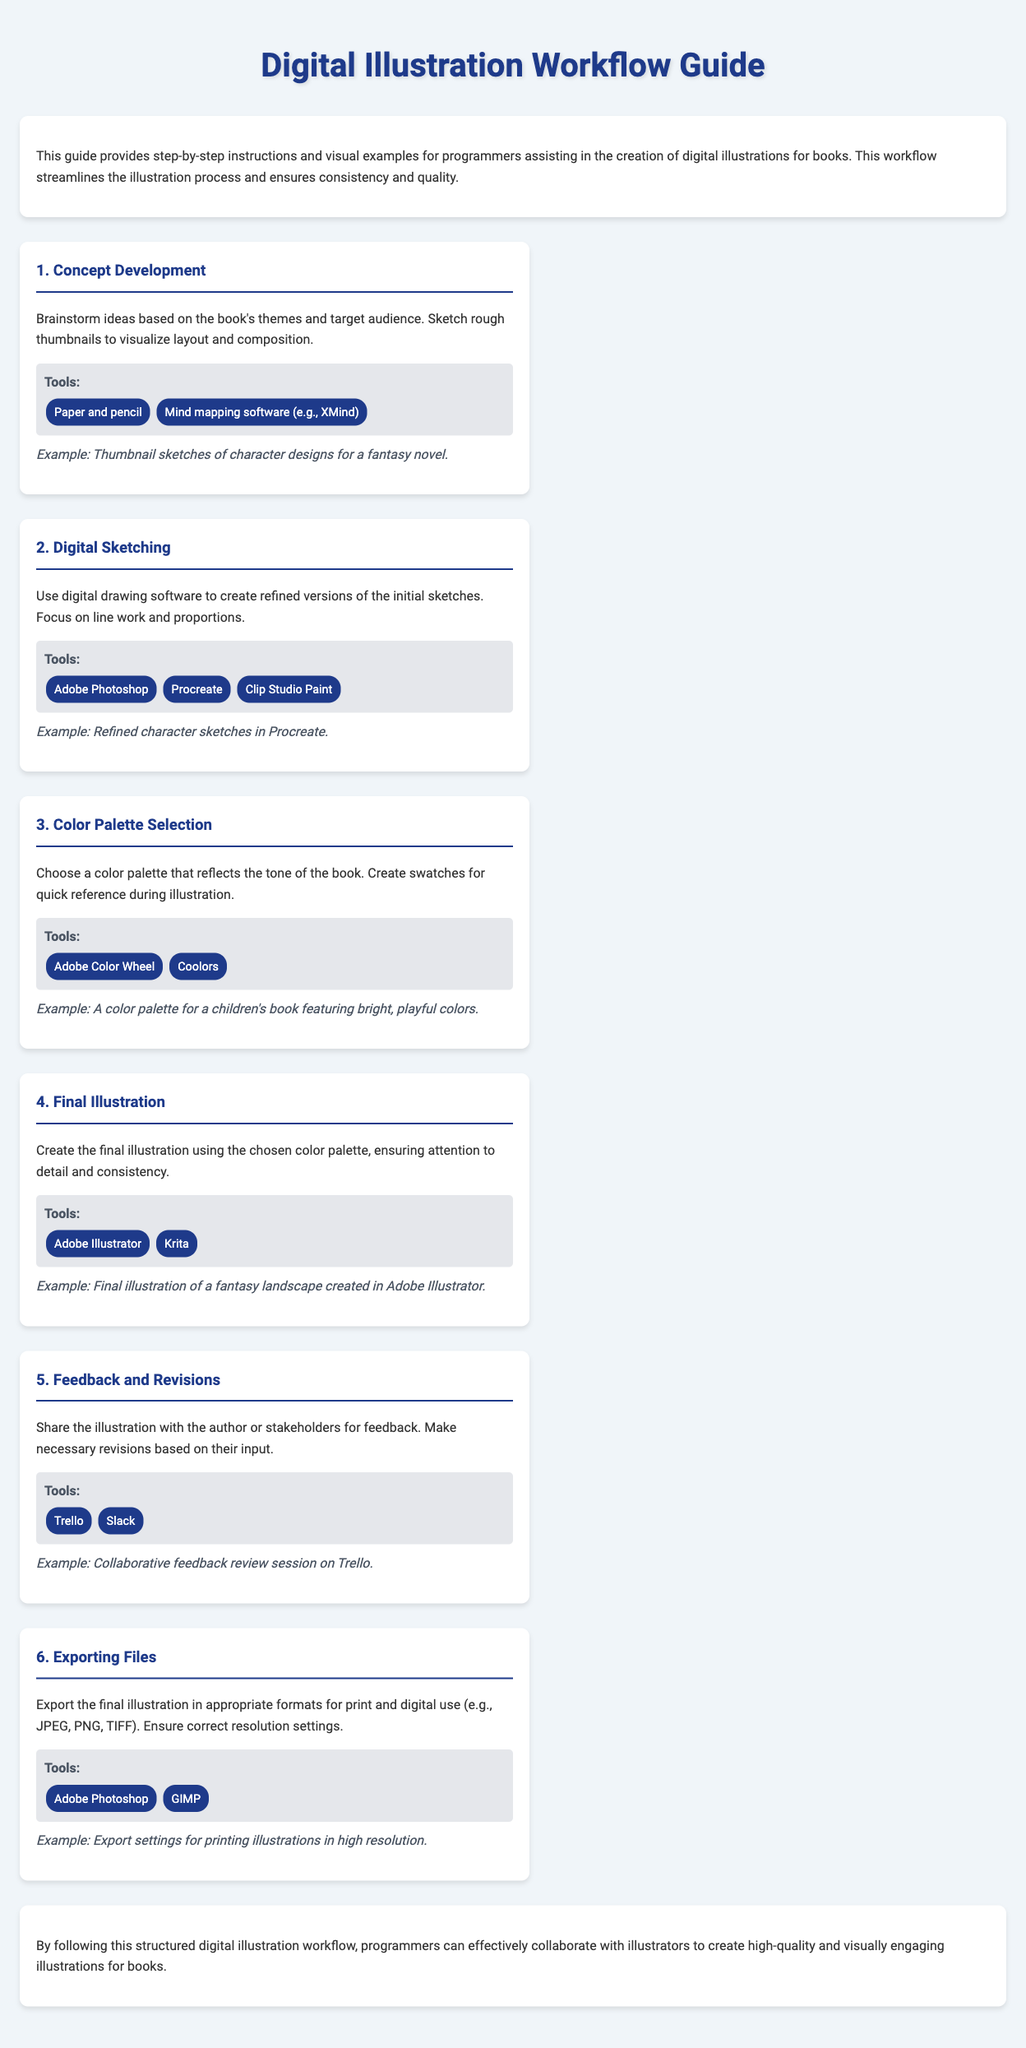What is the title of the document? The title of the document is stated in the header of the guide.
Answer: Digital Illustration Workflow Guide How many steps are in the workflow? The document lists six distinct steps in the workflow.
Answer: 6 Which tool is suggested for digital sketching? The guide provides a list of tools for each step, including specific software tools for digital sketching.
Answer: Procreate What is the focus of the final illustration step? The document specifies the key aspects to consider during the final illustration process.
Answer: Detail and consistency What tool is recommended for feedback and revisions? The document lists tools used in the feedback and revisions stage, highlighting specific collaboration software.
Answer: Trello What is the purpose of the color palette selection step? The document explains the role of selecting a color palette in relation to the tone of the book.
Answer: Reflects the tone of the book What alternate tool can be used for exporting files? The guide includes various tools to use for exporting files in the final step.
Answer: GIMP 